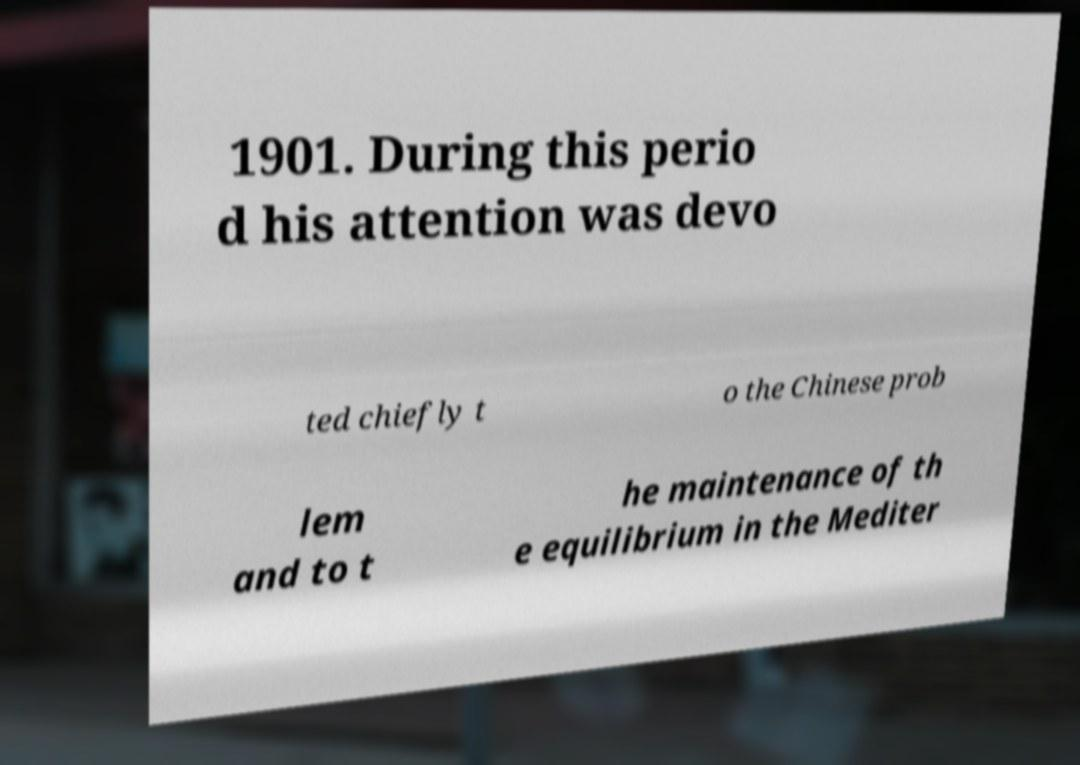Could you assist in decoding the text presented in this image and type it out clearly? 1901. During this perio d his attention was devo ted chiefly t o the Chinese prob lem and to t he maintenance of th e equilibrium in the Mediter 